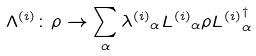<formula> <loc_0><loc_0><loc_500><loc_500>\Lambda ^ { ( i ) } \colon \rho \rightarrow \sum _ { \alpha } { \lambda ^ { ( i ) } } _ { \alpha } { L ^ { ( i ) } } _ { \alpha } \rho { L ^ { ( i ) } } _ { \alpha } ^ { \dagger }</formula> 